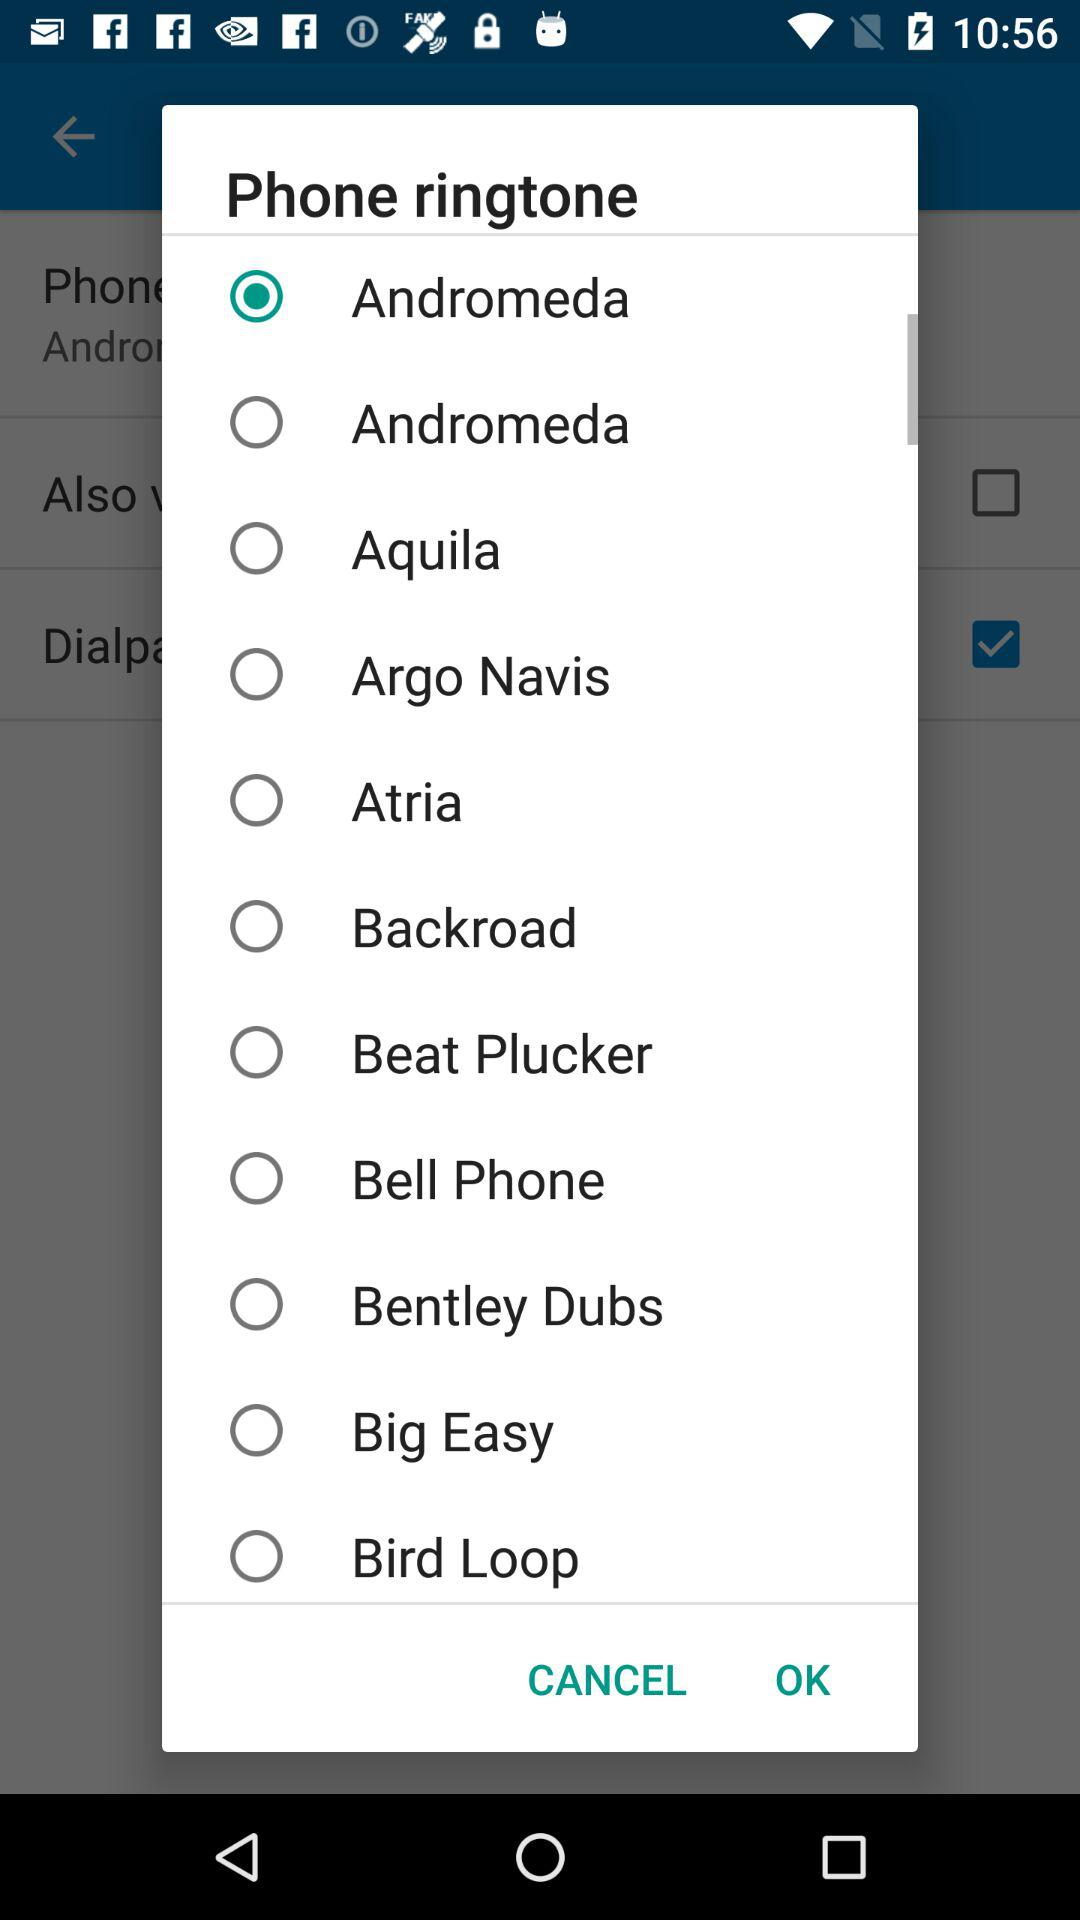What ringtone is selected? The selected ringtone is "Andromeda". 